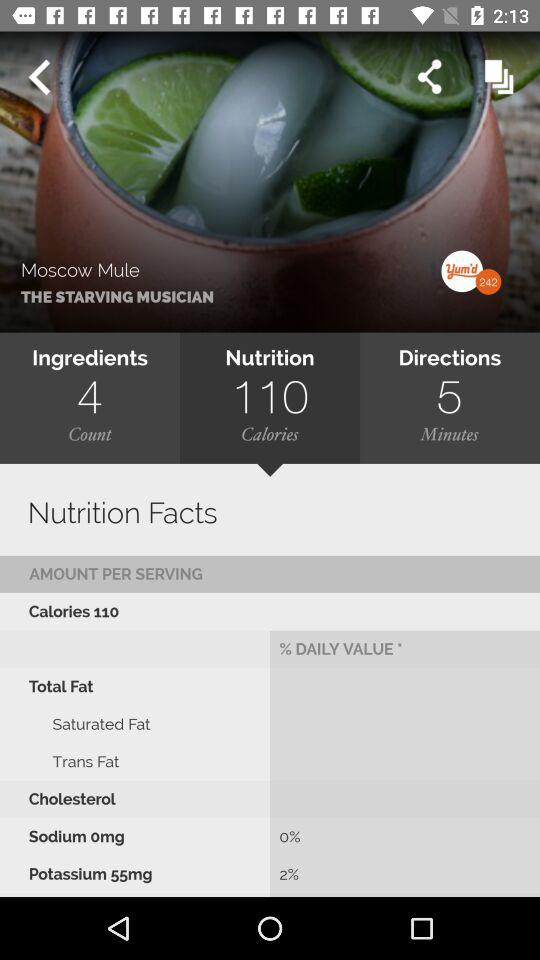What is the duration in "Directions"? The duration in "Directions" is 5 minutes. 